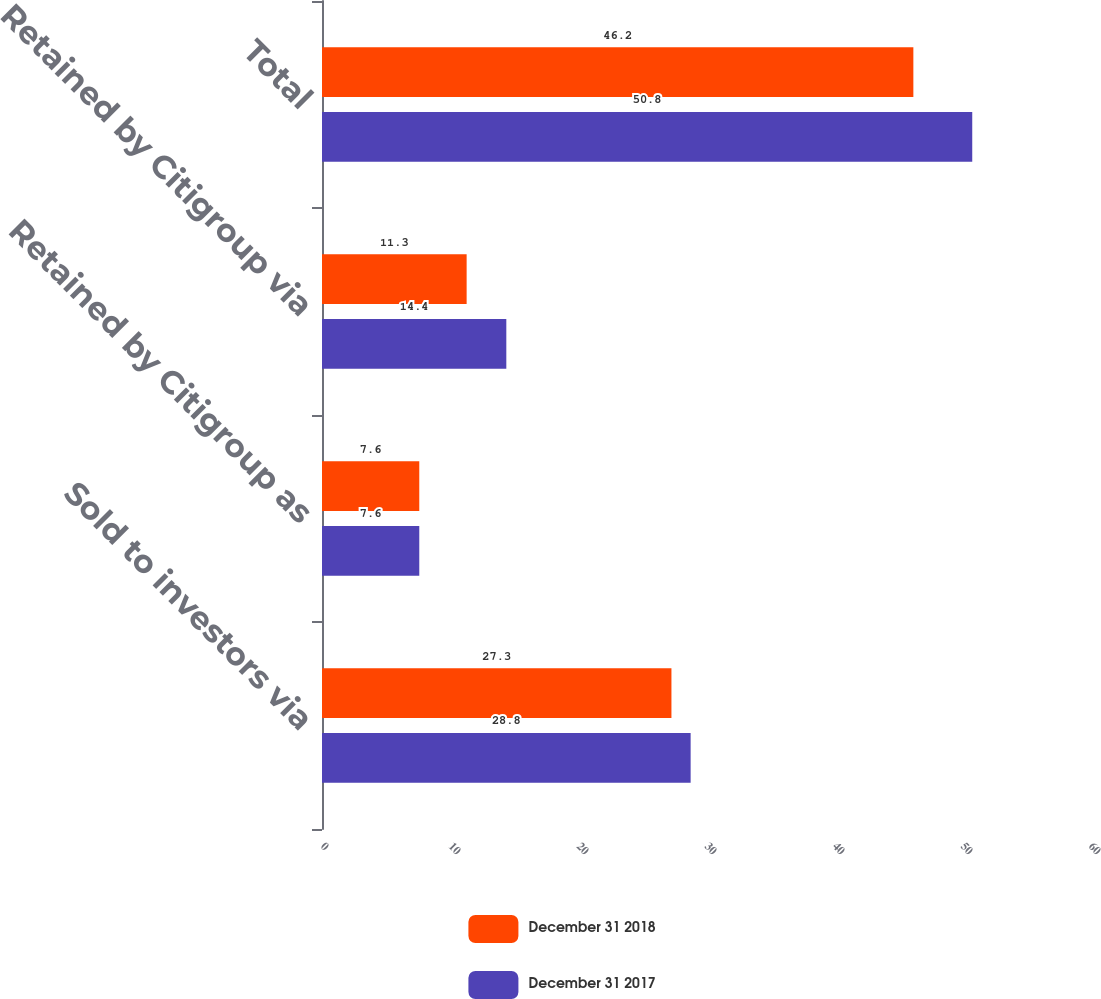<chart> <loc_0><loc_0><loc_500><loc_500><stacked_bar_chart><ecel><fcel>Sold to investors via<fcel>Retained by Citigroup as<fcel>Retained by Citigroup via<fcel>Total<nl><fcel>December 31 2018<fcel>27.3<fcel>7.6<fcel>11.3<fcel>46.2<nl><fcel>December 31 2017<fcel>28.8<fcel>7.6<fcel>14.4<fcel>50.8<nl></chart> 